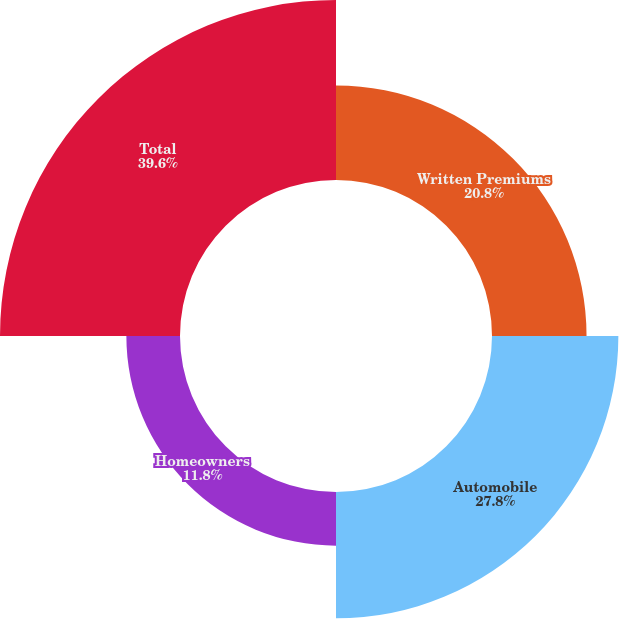Convert chart to OTSL. <chart><loc_0><loc_0><loc_500><loc_500><pie_chart><fcel>Written Premiums<fcel>Automobile<fcel>Homeowners<fcel>Total<nl><fcel>20.8%<fcel>27.8%<fcel>11.8%<fcel>39.6%<nl></chart> 